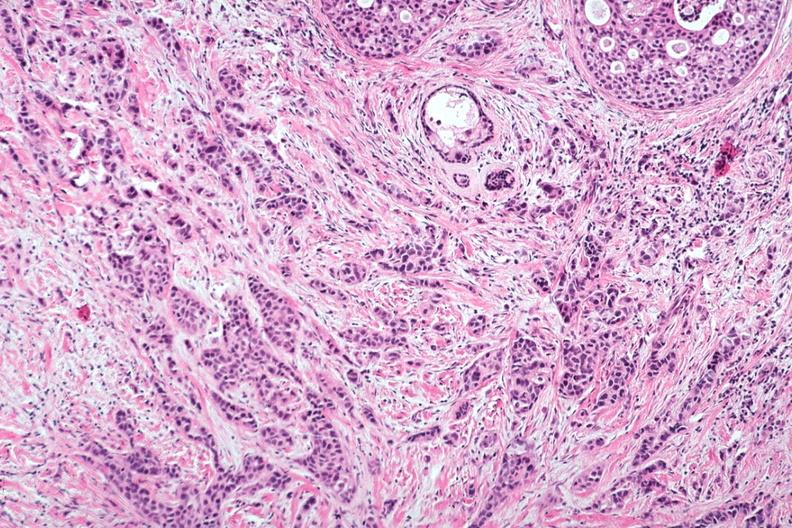s an opened peritoneal cavity cause by fibrous band strangulation present?
Answer the question using a single word or phrase. No 